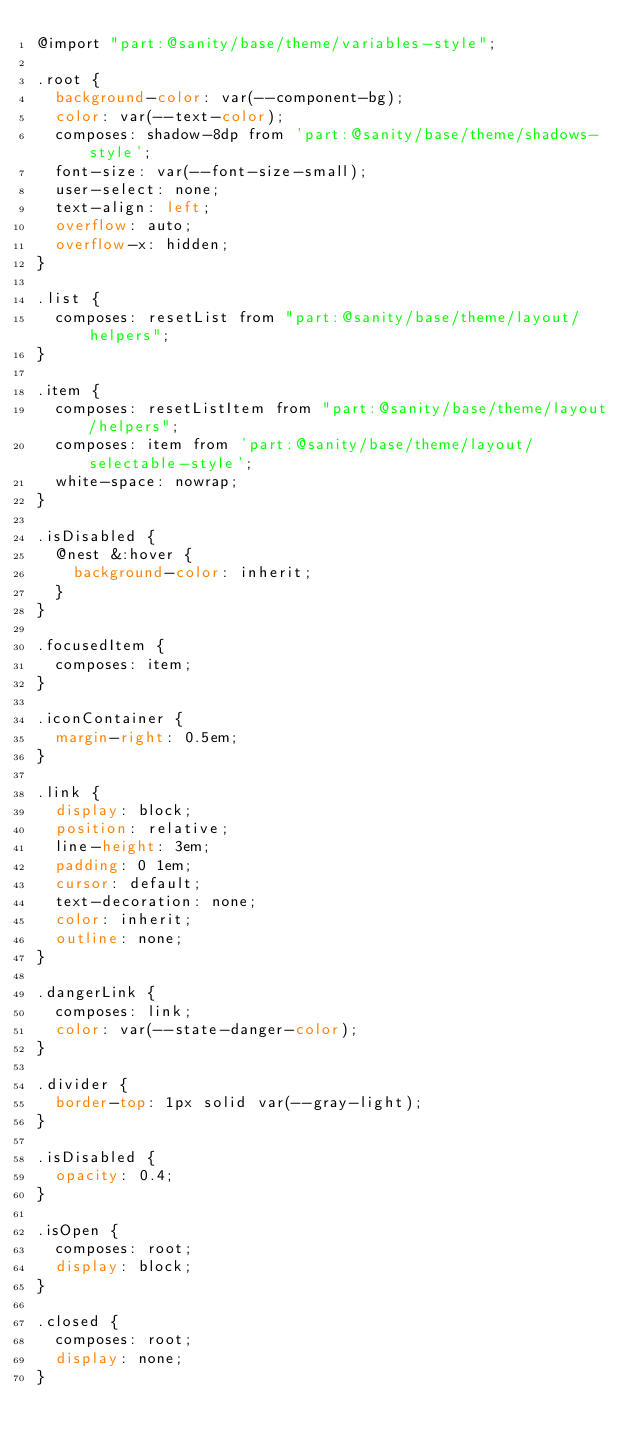Convert code to text. <code><loc_0><loc_0><loc_500><loc_500><_CSS_>@import "part:@sanity/base/theme/variables-style";

.root {
  background-color: var(--component-bg);
  color: var(--text-color);
  composes: shadow-8dp from 'part:@sanity/base/theme/shadows-style';
  font-size: var(--font-size-small);
  user-select: none;
  text-align: left;
  overflow: auto;
  overflow-x: hidden;
}

.list {
  composes: resetList from "part:@sanity/base/theme/layout/helpers";
}

.item {
  composes: resetListItem from "part:@sanity/base/theme/layout/helpers";
  composes: item from 'part:@sanity/base/theme/layout/selectable-style';
  white-space: nowrap;
}

.isDisabled {
  @nest &:hover {
    background-color: inherit;
  }
}

.focusedItem {
  composes: item;
}

.iconContainer {
  margin-right: 0.5em;
}

.link {
  display: block;
  position: relative;
  line-height: 3em;
  padding: 0 1em;
  cursor: default;
  text-decoration: none;
  color: inherit;
  outline: none;
}

.dangerLink {
  composes: link;
  color: var(--state-danger-color);
}

.divider {
  border-top: 1px solid var(--gray-light);
}

.isDisabled {
  opacity: 0.4;
}

.isOpen {
  composes: root;
  display: block;
}

.closed {
  composes: root;
  display: none;
}
</code> 